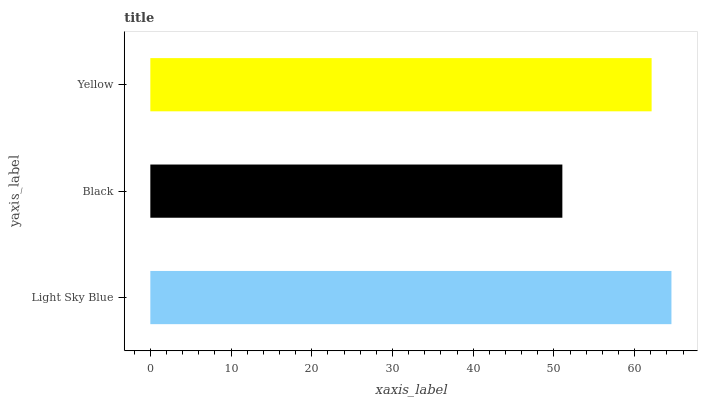Is Black the minimum?
Answer yes or no. Yes. Is Light Sky Blue the maximum?
Answer yes or no. Yes. Is Yellow the minimum?
Answer yes or no. No. Is Yellow the maximum?
Answer yes or no. No. Is Yellow greater than Black?
Answer yes or no. Yes. Is Black less than Yellow?
Answer yes or no. Yes. Is Black greater than Yellow?
Answer yes or no. No. Is Yellow less than Black?
Answer yes or no. No. Is Yellow the high median?
Answer yes or no. Yes. Is Yellow the low median?
Answer yes or no. Yes. Is Light Sky Blue the high median?
Answer yes or no. No. Is Black the low median?
Answer yes or no. No. 